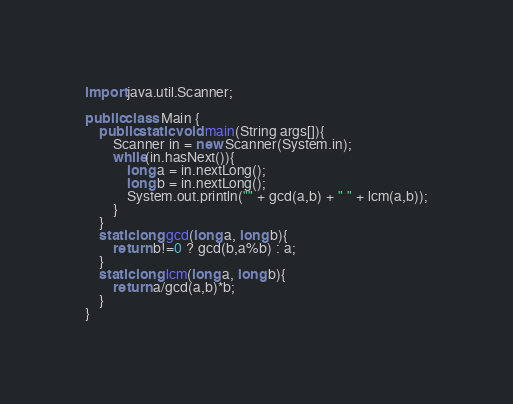Convert code to text. <code><loc_0><loc_0><loc_500><loc_500><_Java_>import java.util.Scanner;

public class Main {
    public static void main(String args[]){
        Scanner in = new Scanner(System.in);
        while(in.hasNext()){
            long a = in.nextLong();
            long b = in.nextLong();
            System.out.println("" + gcd(a,b) + " " + lcm(a,b));
        }
    }
    static long gcd(long a, long b){
        return b!=0 ? gcd(b,a%b) : a;
    }
    static long lcm(long a, long b){
        return a/gcd(a,b)*b;
    }
}</code> 